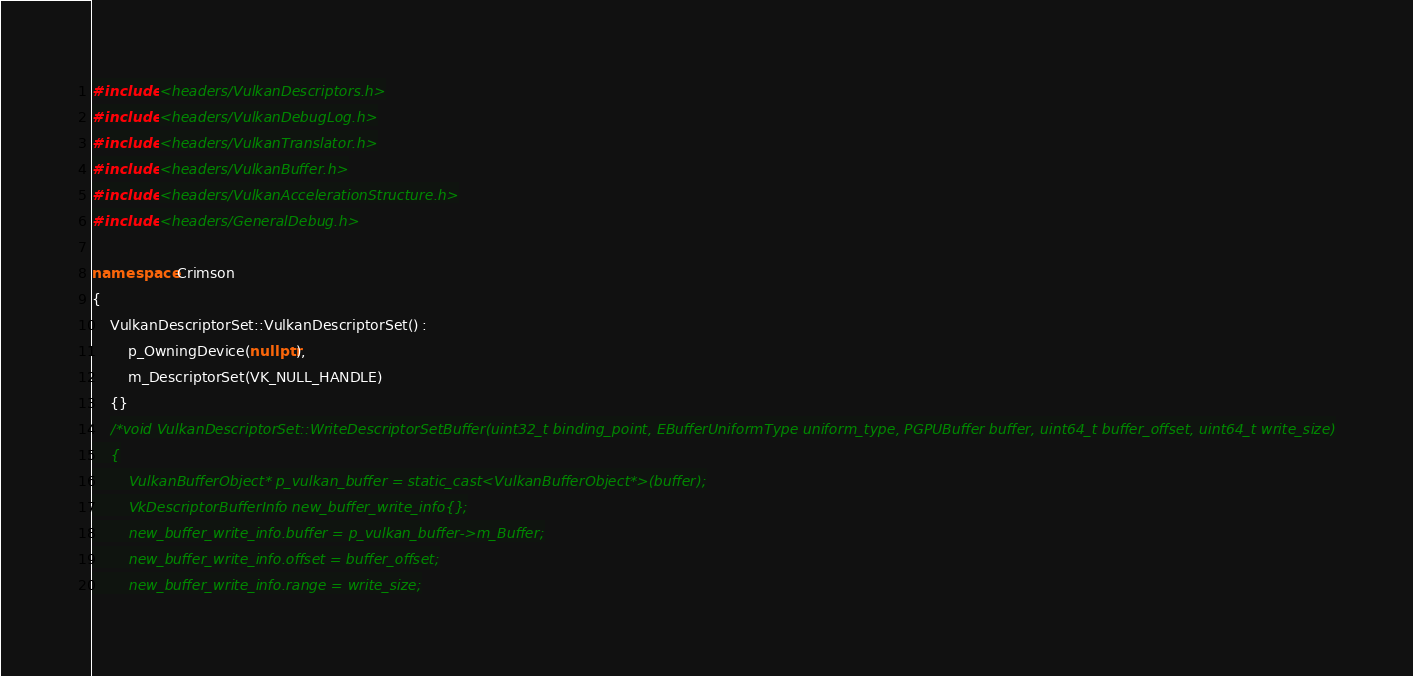<code> <loc_0><loc_0><loc_500><loc_500><_C++_>#include <headers/VulkanDescriptors.h>
#include <headers/VulkanDebugLog.h>
#include <headers/VulkanTranslator.h>
#include <headers/VulkanBuffer.h>
#include <headers/VulkanAccelerationStructure.h>
#include <headers/GeneralDebug.h>

namespace Crimson
{
	VulkanDescriptorSet::VulkanDescriptorSet() : 
		p_OwningDevice(nullptr),
		m_DescriptorSet(VK_NULL_HANDLE)
	{}
	/*void VulkanDescriptorSet::WriteDescriptorSetBuffer(uint32_t binding_point, EBufferUniformType uniform_type, PGPUBuffer buffer, uint64_t buffer_offset, uint64_t write_size)
	{
		VulkanBufferObject* p_vulkan_buffer = static_cast<VulkanBufferObject*>(buffer);
		VkDescriptorBufferInfo new_buffer_write_info{};
		new_buffer_write_info.buffer = p_vulkan_buffer->m_Buffer;
		new_buffer_write_info.offset = buffer_offset;
		new_buffer_write_info.range = write_size;</code> 